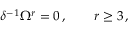<formula> <loc_0><loc_0><loc_500><loc_500>\delta ^ { - 1 } \Omega ^ { r } = 0 \, , \quad r \geq 3 \, ,</formula> 